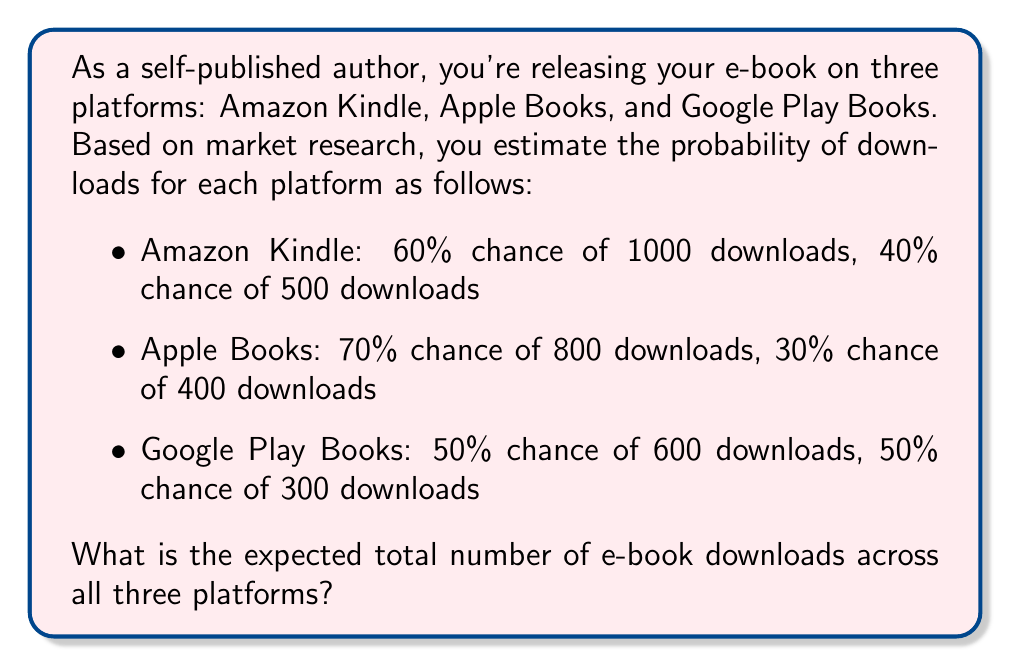Can you solve this math problem? To solve this problem, we need to calculate the expected value for each platform and then sum them up. Let's break it down step-by-step:

1. Calculate the expected value for Amazon Kindle:
   $$E(Kindle) = 0.60 \times 1000 + 0.40 \times 500 = 600 + 200 = 800$$

2. Calculate the expected value for Apple Books:
   $$E(Apple) = 0.70 \times 800 + 0.30 \times 400 = 560 + 120 = 680$$

3. Calculate the expected value for Google Play Books:
   $$E(Google) = 0.50 \times 600 + 0.50 \times 300 = 300 + 150 = 450$$

4. Sum up the expected values from all three platforms:
   $$E(Total) = E(Kindle) + E(Apple) + E(Google)$$
   $$E(Total) = 800 + 680 + 450 = 1930$$

Therefore, the expected total number of e-book downloads across all three platforms is 1930.
Answer: 1930 downloads 